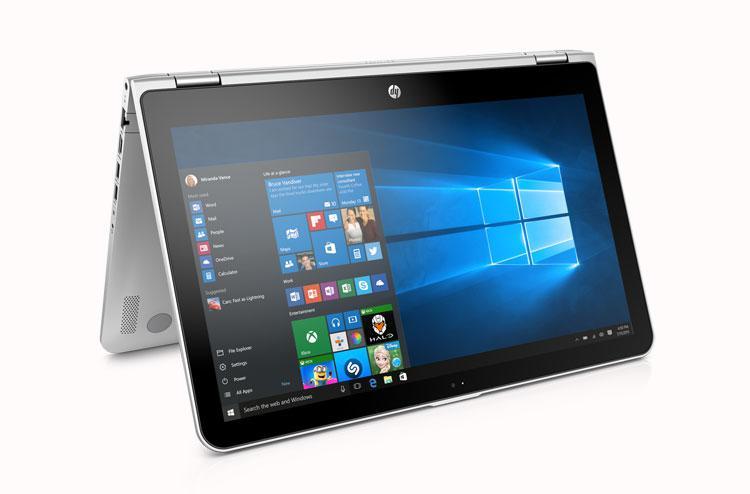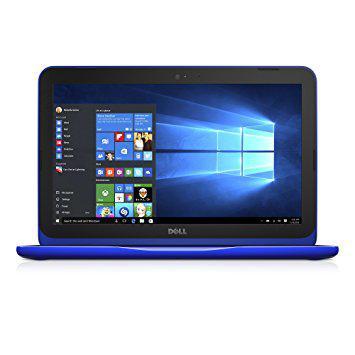The first image is the image on the left, the second image is the image on the right. Evaluate the accuracy of this statement regarding the images: "There is one laptop shown front and back.". Is it true? Answer yes or no. No. 